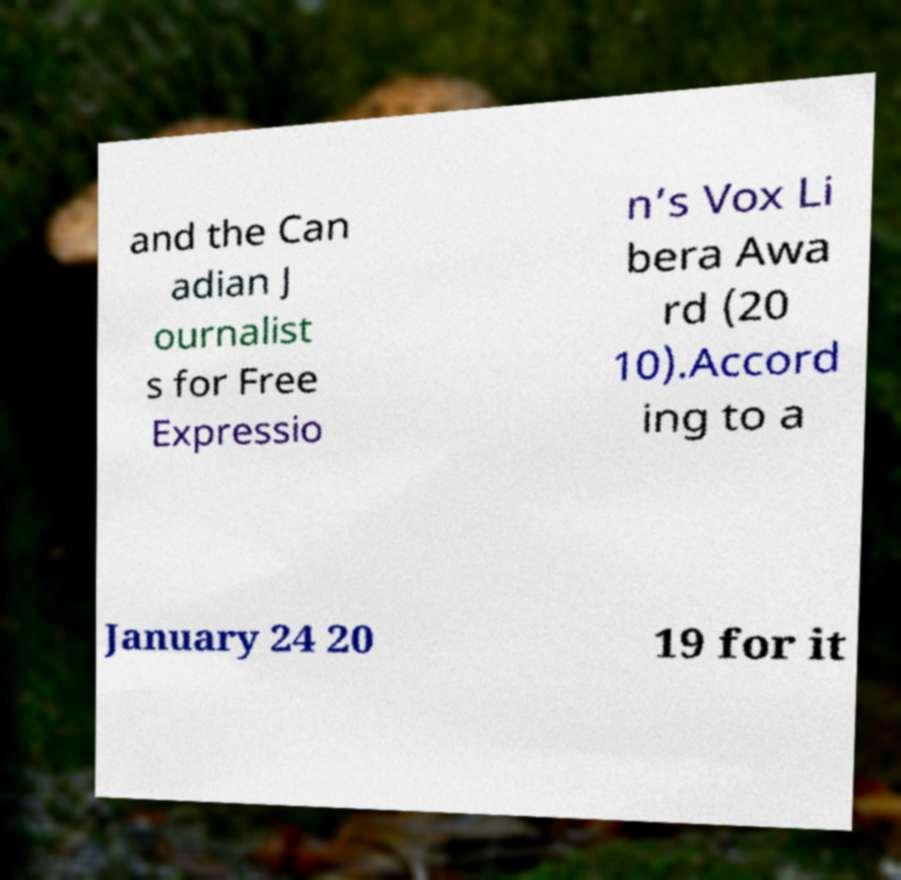Could you assist in decoding the text presented in this image and type it out clearly? and the Can adian J ournalist s for Free Expressio n’s Vox Li bera Awa rd (20 10).Accord ing to a January 24 20 19 for it 